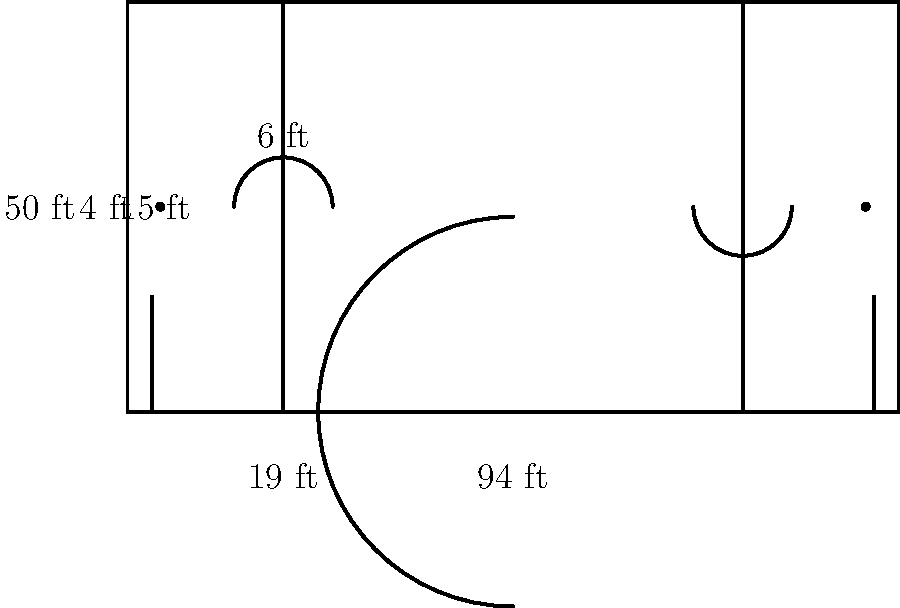Looking at the diagram of a basketball court, what is the distance between the free throw line and the baseline (the line under the basket)? To find the distance between the free throw line and the baseline, we need to follow these steps:

1. Identify the baseline: This is the line under the basket, at the short end of the court.

2. Locate the free throw line: This is the line parallel to the baseline, from which free throws are taken.

3. Find the labeled distance: The diagram shows a label of "15 ft" pointing to the space between the baseline and the free throw line.

4. Understand the context: In basketball, the free throw line is always 15 feet from the baseline. This is a standard measurement in all regulation basketball courts.

5. Confirm the answer: The 15-foot distance is consistent with official basketball court dimensions, verifying that this is the correct measurement we're looking for.

Therefore, the distance between the free throw line and the baseline is 15 feet.
Answer: 15 feet 